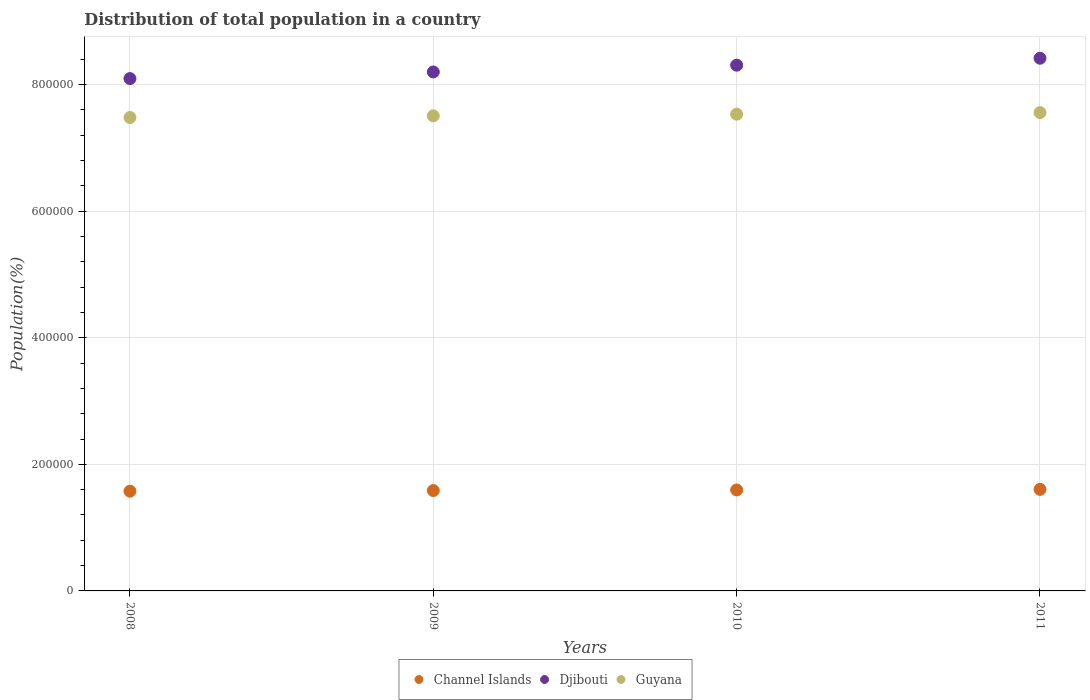How many different coloured dotlines are there?
Provide a short and direct response. 3. Is the number of dotlines equal to the number of legend labels?
Offer a terse response. Yes. What is the population of in Djibouti in 2009?
Your answer should be very brief. 8.20e+05. Across all years, what is the maximum population of in Guyana?
Your response must be concise. 7.56e+05. Across all years, what is the minimum population of in Djibouti?
Ensure brevity in your answer.  8.10e+05. What is the total population of in Channel Islands in the graph?
Your answer should be compact. 6.36e+05. What is the difference between the population of in Djibouti in 2009 and that in 2010?
Your answer should be compact. -1.07e+04. What is the difference between the population of in Djibouti in 2010 and the population of in Guyana in 2009?
Your answer should be very brief. 8.01e+04. What is the average population of in Guyana per year?
Your response must be concise. 7.52e+05. In the year 2008, what is the difference between the population of in Channel Islands and population of in Guyana?
Offer a terse response. -5.91e+05. What is the ratio of the population of in Djibouti in 2009 to that in 2010?
Your answer should be very brief. 0.99. Is the population of in Djibouti in 2008 less than that in 2011?
Your response must be concise. Yes. Is the difference between the population of in Channel Islands in 2009 and 2011 greater than the difference between the population of in Guyana in 2009 and 2011?
Provide a succinct answer. Yes. What is the difference between the highest and the second highest population of in Djibouti?
Make the answer very short. 1.10e+04. What is the difference between the highest and the lowest population of in Guyana?
Offer a very short reply. 7787. How many years are there in the graph?
Your response must be concise. 4. Does the graph contain any zero values?
Your response must be concise. No. Where does the legend appear in the graph?
Provide a succinct answer. Bottom center. What is the title of the graph?
Make the answer very short. Distribution of total population in a country. Does "Azerbaijan" appear as one of the legend labels in the graph?
Your answer should be compact. No. What is the label or title of the X-axis?
Offer a very short reply. Years. What is the label or title of the Y-axis?
Make the answer very short. Population(%). What is the Population(%) of Channel Islands in 2008?
Your answer should be very brief. 1.58e+05. What is the Population(%) in Djibouti in 2008?
Ensure brevity in your answer.  8.10e+05. What is the Population(%) in Guyana in 2008?
Offer a terse response. 7.48e+05. What is the Population(%) in Channel Islands in 2009?
Your answer should be very brief. 1.59e+05. What is the Population(%) of Djibouti in 2009?
Provide a short and direct response. 8.20e+05. What is the Population(%) in Guyana in 2009?
Provide a succinct answer. 7.51e+05. What is the Population(%) of Channel Islands in 2010?
Provide a short and direct response. 1.60e+05. What is the Population(%) of Djibouti in 2010?
Offer a very short reply. 8.31e+05. What is the Population(%) in Guyana in 2010?
Offer a very short reply. 7.53e+05. What is the Population(%) in Channel Islands in 2011?
Ensure brevity in your answer.  1.60e+05. What is the Population(%) of Djibouti in 2011?
Offer a terse response. 8.42e+05. What is the Population(%) in Guyana in 2011?
Provide a succinct answer. 7.56e+05. Across all years, what is the maximum Population(%) of Channel Islands?
Offer a very short reply. 1.60e+05. Across all years, what is the maximum Population(%) in Djibouti?
Provide a succinct answer. 8.42e+05. Across all years, what is the maximum Population(%) in Guyana?
Your answer should be very brief. 7.56e+05. Across all years, what is the minimum Population(%) in Channel Islands?
Your answer should be compact. 1.58e+05. Across all years, what is the minimum Population(%) of Djibouti?
Give a very brief answer. 8.10e+05. Across all years, what is the minimum Population(%) of Guyana?
Your answer should be very brief. 7.48e+05. What is the total Population(%) of Channel Islands in the graph?
Offer a very short reply. 6.36e+05. What is the total Population(%) of Djibouti in the graph?
Make the answer very short. 3.30e+06. What is the total Population(%) in Guyana in the graph?
Your answer should be very brief. 3.01e+06. What is the difference between the Population(%) in Channel Islands in 2008 and that in 2009?
Your response must be concise. -1026. What is the difference between the Population(%) of Djibouti in 2008 and that in 2009?
Offer a terse response. -1.05e+04. What is the difference between the Population(%) of Guyana in 2008 and that in 2009?
Your answer should be very brief. -2653. What is the difference between the Population(%) in Channel Islands in 2008 and that in 2010?
Offer a terse response. -1996. What is the difference between the Population(%) in Djibouti in 2008 and that in 2010?
Make the answer very short. -2.12e+04. What is the difference between the Population(%) in Guyana in 2008 and that in 2010?
Give a very brief answer. -5266. What is the difference between the Population(%) of Channel Islands in 2008 and that in 2011?
Keep it short and to the point. -2902. What is the difference between the Population(%) of Djibouti in 2008 and that in 2011?
Give a very brief answer. -3.22e+04. What is the difference between the Population(%) in Guyana in 2008 and that in 2011?
Provide a succinct answer. -7787. What is the difference between the Population(%) in Channel Islands in 2009 and that in 2010?
Offer a very short reply. -970. What is the difference between the Population(%) in Djibouti in 2009 and that in 2010?
Provide a succinct answer. -1.07e+04. What is the difference between the Population(%) of Guyana in 2009 and that in 2010?
Provide a succinct answer. -2613. What is the difference between the Population(%) of Channel Islands in 2009 and that in 2011?
Your response must be concise. -1876. What is the difference between the Population(%) in Djibouti in 2009 and that in 2011?
Offer a very short reply. -2.17e+04. What is the difference between the Population(%) in Guyana in 2009 and that in 2011?
Provide a short and direct response. -5134. What is the difference between the Population(%) of Channel Islands in 2010 and that in 2011?
Offer a terse response. -906. What is the difference between the Population(%) in Djibouti in 2010 and that in 2011?
Ensure brevity in your answer.  -1.10e+04. What is the difference between the Population(%) in Guyana in 2010 and that in 2011?
Your answer should be compact. -2521. What is the difference between the Population(%) in Channel Islands in 2008 and the Population(%) in Djibouti in 2009?
Your response must be concise. -6.63e+05. What is the difference between the Population(%) in Channel Islands in 2008 and the Population(%) in Guyana in 2009?
Offer a terse response. -5.93e+05. What is the difference between the Population(%) in Djibouti in 2008 and the Population(%) in Guyana in 2009?
Offer a very short reply. 5.89e+04. What is the difference between the Population(%) in Channel Islands in 2008 and the Population(%) in Djibouti in 2010?
Your response must be concise. -6.73e+05. What is the difference between the Population(%) of Channel Islands in 2008 and the Population(%) of Guyana in 2010?
Make the answer very short. -5.96e+05. What is the difference between the Population(%) in Djibouti in 2008 and the Population(%) in Guyana in 2010?
Keep it short and to the point. 5.63e+04. What is the difference between the Population(%) in Channel Islands in 2008 and the Population(%) in Djibouti in 2011?
Keep it short and to the point. -6.84e+05. What is the difference between the Population(%) in Channel Islands in 2008 and the Population(%) in Guyana in 2011?
Offer a terse response. -5.98e+05. What is the difference between the Population(%) of Djibouti in 2008 and the Population(%) of Guyana in 2011?
Your response must be concise. 5.38e+04. What is the difference between the Population(%) of Channel Islands in 2009 and the Population(%) of Djibouti in 2010?
Offer a very short reply. -6.72e+05. What is the difference between the Population(%) in Channel Islands in 2009 and the Population(%) in Guyana in 2010?
Make the answer very short. -5.95e+05. What is the difference between the Population(%) in Djibouti in 2009 and the Population(%) in Guyana in 2010?
Keep it short and to the point. 6.67e+04. What is the difference between the Population(%) of Channel Islands in 2009 and the Population(%) of Djibouti in 2011?
Provide a short and direct response. -6.83e+05. What is the difference between the Population(%) in Channel Islands in 2009 and the Population(%) in Guyana in 2011?
Make the answer very short. -5.97e+05. What is the difference between the Population(%) in Djibouti in 2009 and the Population(%) in Guyana in 2011?
Your response must be concise. 6.42e+04. What is the difference between the Population(%) of Channel Islands in 2010 and the Population(%) of Djibouti in 2011?
Your answer should be compact. -6.82e+05. What is the difference between the Population(%) in Channel Islands in 2010 and the Population(%) in Guyana in 2011?
Offer a terse response. -5.96e+05. What is the difference between the Population(%) in Djibouti in 2010 and the Population(%) in Guyana in 2011?
Give a very brief answer. 7.49e+04. What is the average Population(%) of Channel Islands per year?
Make the answer very short. 1.59e+05. What is the average Population(%) of Djibouti per year?
Your answer should be compact. 8.26e+05. What is the average Population(%) in Guyana per year?
Your response must be concise. 7.52e+05. In the year 2008, what is the difference between the Population(%) in Channel Islands and Population(%) in Djibouti?
Your response must be concise. -6.52e+05. In the year 2008, what is the difference between the Population(%) of Channel Islands and Population(%) of Guyana?
Provide a short and direct response. -5.91e+05. In the year 2008, what is the difference between the Population(%) of Djibouti and Population(%) of Guyana?
Your answer should be very brief. 6.15e+04. In the year 2009, what is the difference between the Population(%) in Channel Islands and Population(%) in Djibouti?
Keep it short and to the point. -6.61e+05. In the year 2009, what is the difference between the Population(%) of Channel Islands and Population(%) of Guyana?
Offer a very short reply. -5.92e+05. In the year 2009, what is the difference between the Population(%) of Djibouti and Population(%) of Guyana?
Provide a short and direct response. 6.93e+04. In the year 2010, what is the difference between the Population(%) in Channel Islands and Population(%) in Djibouti?
Offer a very short reply. -6.71e+05. In the year 2010, what is the difference between the Population(%) in Channel Islands and Population(%) in Guyana?
Provide a succinct answer. -5.94e+05. In the year 2010, what is the difference between the Population(%) of Djibouti and Population(%) of Guyana?
Provide a short and direct response. 7.74e+04. In the year 2011, what is the difference between the Population(%) in Channel Islands and Population(%) in Djibouti?
Keep it short and to the point. -6.81e+05. In the year 2011, what is the difference between the Population(%) in Channel Islands and Population(%) in Guyana?
Ensure brevity in your answer.  -5.95e+05. In the year 2011, what is the difference between the Population(%) of Djibouti and Population(%) of Guyana?
Provide a short and direct response. 8.59e+04. What is the ratio of the Population(%) in Djibouti in 2008 to that in 2009?
Keep it short and to the point. 0.99. What is the ratio of the Population(%) of Guyana in 2008 to that in 2009?
Provide a succinct answer. 1. What is the ratio of the Population(%) of Channel Islands in 2008 to that in 2010?
Give a very brief answer. 0.99. What is the ratio of the Population(%) in Djibouti in 2008 to that in 2010?
Make the answer very short. 0.97. What is the ratio of the Population(%) of Guyana in 2008 to that in 2010?
Make the answer very short. 0.99. What is the ratio of the Population(%) in Channel Islands in 2008 to that in 2011?
Provide a succinct answer. 0.98. What is the ratio of the Population(%) of Djibouti in 2008 to that in 2011?
Keep it short and to the point. 0.96. What is the ratio of the Population(%) of Guyana in 2008 to that in 2011?
Your response must be concise. 0.99. What is the ratio of the Population(%) of Channel Islands in 2009 to that in 2010?
Give a very brief answer. 0.99. What is the ratio of the Population(%) of Djibouti in 2009 to that in 2010?
Your response must be concise. 0.99. What is the ratio of the Population(%) of Guyana in 2009 to that in 2010?
Your answer should be very brief. 1. What is the ratio of the Population(%) in Channel Islands in 2009 to that in 2011?
Make the answer very short. 0.99. What is the ratio of the Population(%) in Djibouti in 2009 to that in 2011?
Make the answer very short. 0.97. What is the ratio of the Population(%) in Channel Islands in 2010 to that in 2011?
Give a very brief answer. 0.99. What is the ratio of the Population(%) of Djibouti in 2010 to that in 2011?
Offer a very short reply. 0.99. What is the difference between the highest and the second highest Population(%) of Channel Islands?
Keep it short and to the point. 906. What is the difference between the highest and the second highest Population(%) of Djibouti?
Your response must be concise. 1.10e+04. What is the difference between the highest and the second highest Population(%) of Guyana?
Ensure brevity in your answer.  2521. What is the difference between the highest and the lowest Population(%) in Channel Islands?
Make the answer very short. 2902. What is the difference between the highest and the lowest Population(%) of Djibouti?
Provide a succinct answer. 3.22e+04. What is the difference between the highest and the lowest Population(%) in Guyana?
Keep it short and to the point. 7787. 